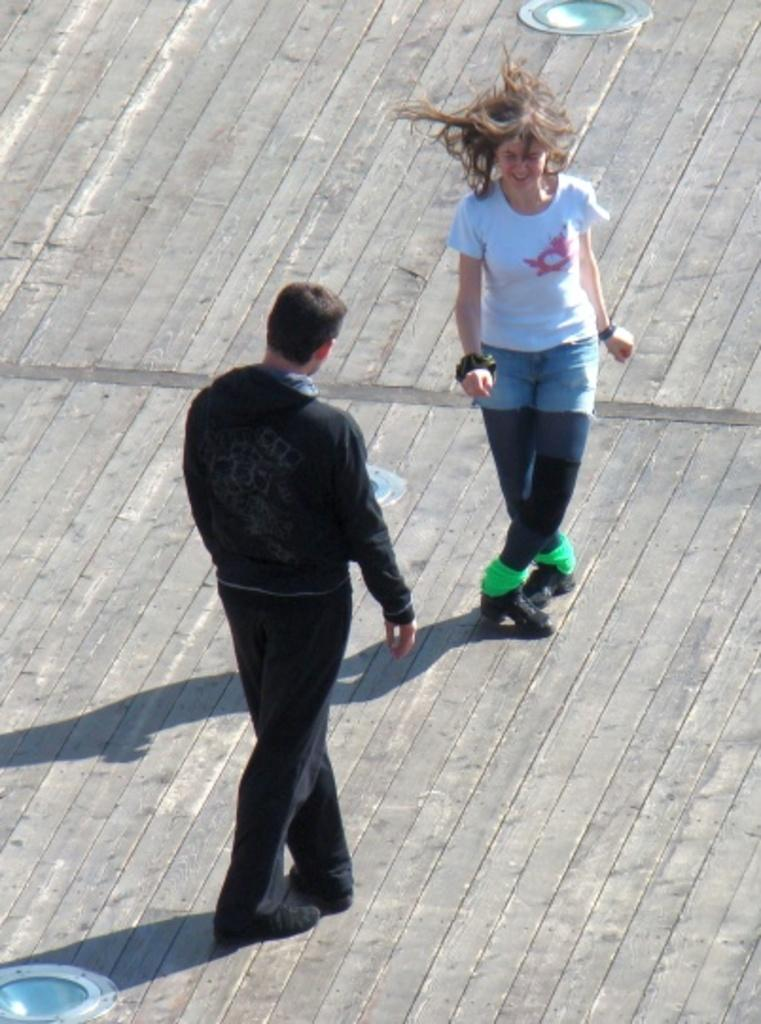Who are the people in the image? There is a man and a woman in the image. What are the man and woman doing in the image? The man and woman are dancing. What type of steel is used to construct the vessel in the image? There is no vessel or steel present in the image; it features a man and a woman dancing. 